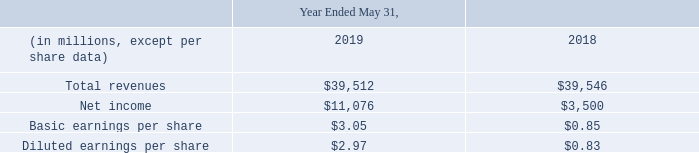Unaudited Pro Forma Financial Information
The unaudited pro forma financial information in the table below summarizes the combined results of operations for Oracle, Aconex and certain other companies that we acquired since the beginning of fiscal 2018 that were considered relevant for the purposes of unaudited pro forma financial information disclosure as if the companies were combined as of the beginning of fiscal 2018. The unaudited pro forma financial information for all periods presented included the business combination accounting effects resulting from these acquisitions, including amortization charges from acquired intangible assets (certain of which are preliminary), stock-based compensation charges for unvested restricted stock-based awards and stock options assumed, if any, and the related tax effects as though the aforementioned companies were combined as of the beginning of fiscal 2018. The unaudited pro forma financial information as presented below is for informational purposes only and is not necessarily indicative of the results of operations that would have been achieved if the acquisitions had taken place at the beginning of fiscal 2018 or 2019.
The unaudited pro forma financial information for fiscal 2019 presented the historical results of Oracle for fiscal 2019 and certain other companies that we acquired since the beginning of fiscal 2019 based upon their respective previous reporting periods and the dates these companies were acquired by us, and the effects of the pro forma adjustments listed above.
The unaudited pro forma financial information for fiscal 2018 combined the historical results of Oracle for fiscal 201 8 and the historical results of Aconex for the twelve month period ended December 31, 2017 (adjusted due to differences in reporting periods and considering the date we acquired Aconex) and certain other companies that we acquired since the beginning of fiscal 201 8 based upon their respective previous reporting periods and the dates these companies were acquired by us, and the effects of the pro forma adjustments listed above. The unaudited pro forma financial information was as follows:
What does the unaudited pro forma financial information summarize? The unaudited pro forma financial information in the table below summarizes the combined results of operations for oracle, aconex and certain other companies that we acquired since the beginning of fiscal 2018 that were considered relevant for the purposes of unaudited pro forma financial information disclosure as if the companies were combined as of the beginning of fiscal 2018. How much was the total revenue in 2019?
Answer scale should be: million. 39,512. How much were the basic earnings per share in 2018? $0.85. What was the average basic earnings per share over a 2 year period from 2018 to 2019? (3.05+0.85)/2 
Answer: 1.95. What was the average total revenue over a 2 year period from 2018 to 2019?
Answer scale should be: million. (39,512+ 39,546)/2 
Answer: 39529. What was the average diluted earnings per share over a 2 year period from 2018 to 2019? (0.83+2.97)/2
Answer: 1.9. 